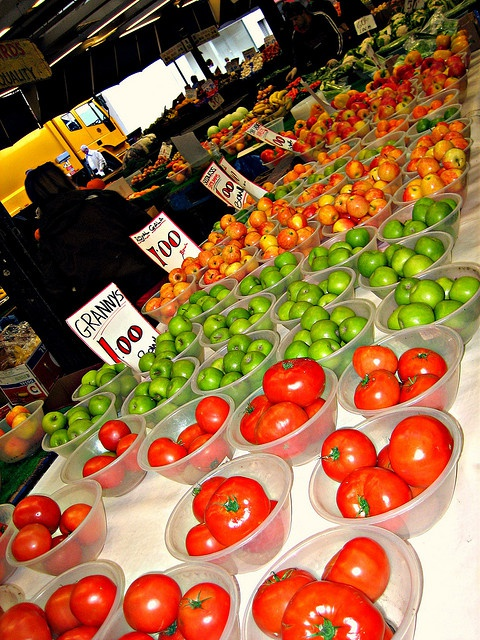Describe the objects in this image and their specific colors. I can see bowl in black, red, olive, and brown tones, apple in black, olive, and red tones, bowl in black, red, ivory, and tan tones, people in black, orange, and maroon tones, and bowl in black, tan, and red tones in this image. 